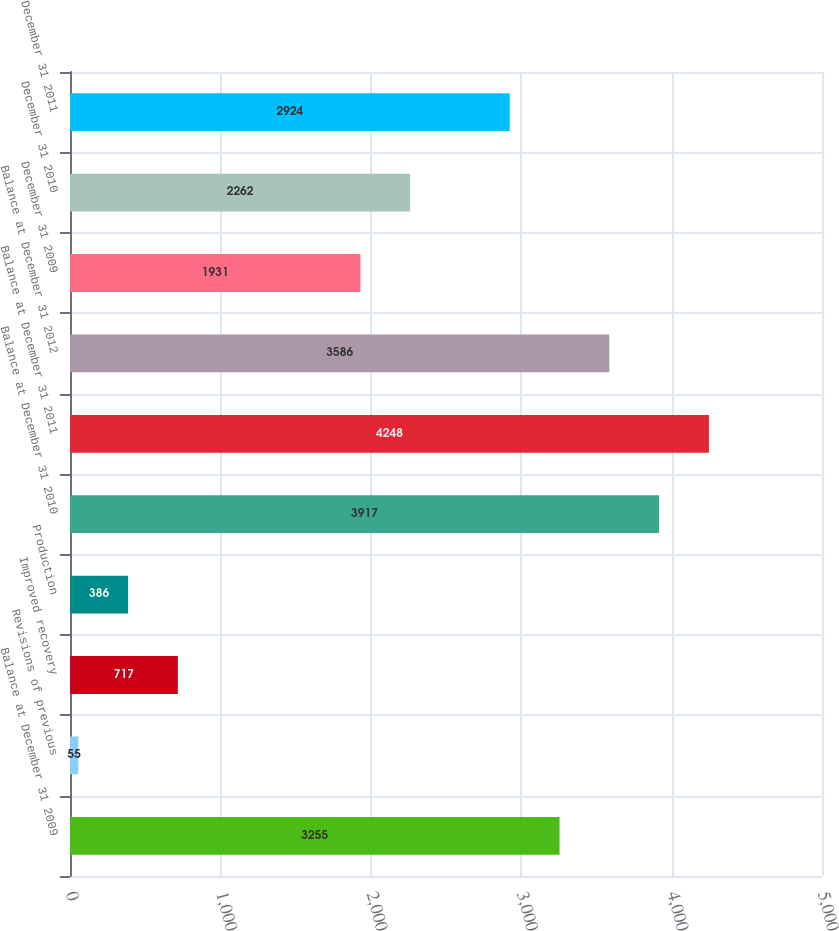<chart> <loc_0><loc_0><loc_500><loc_500><bar_chart><fcel>Balance at December 31 2009<fcel>Revisions of previous<fcel>Improved recovery<fcel>Production<fcel>Balance at December 31 2010<fcel>Balance at December 31 2011<fcel>Balance at December 31 2012<fcel>December 31 2009<fcel>December 31 2010<fcel>December 31 2011<nl><fcel>3255<fcel>55<fcel>717<fcel>386<fcel>3917<fcel>4248<fcel>3586<fcel>1931<fcel>2262<fcel>2924<nl></chart> 